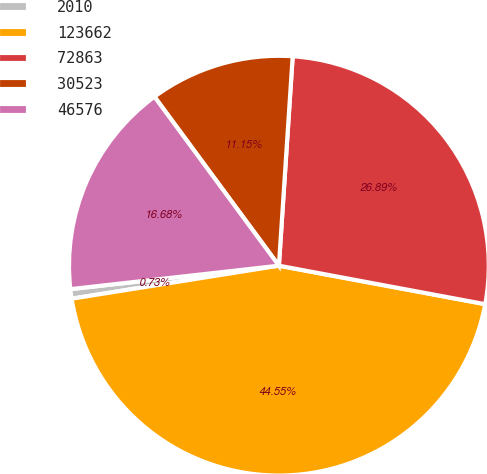Convert chart to OTSL. <chart><loc_0><loc_0><loc_500><loc_500><pie_chart><fcel>2010<fcel>123662<fcel>72863<fcel>30523<fcel>46576<nl><fcel>0.73%<fcel>44.55%<fcel>26.89%<fcel>11.15%<fcel>16.68%<nl></chart> 